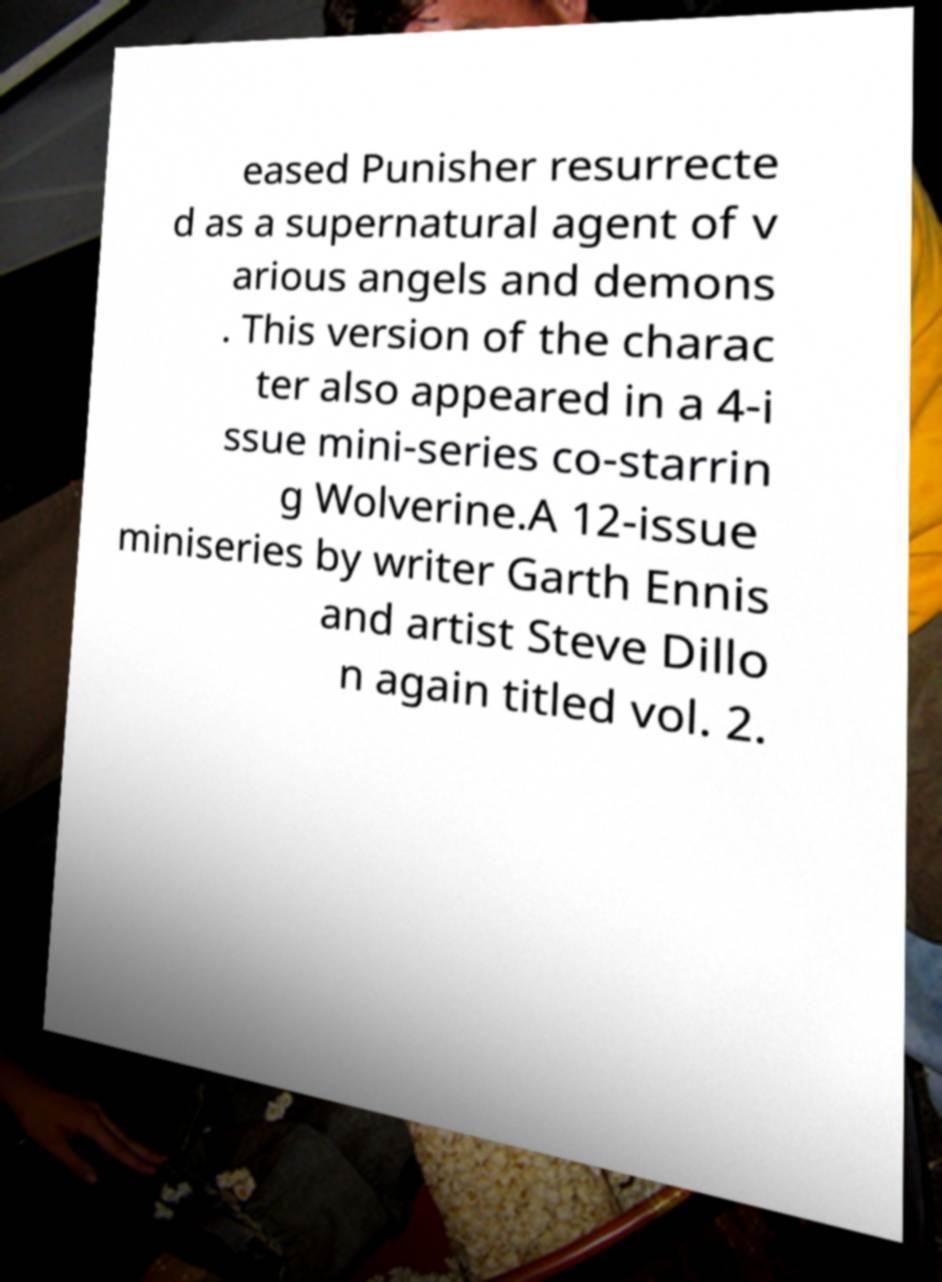There's text embedded in this image that I need extracted. Can you transcribe it verbatim? eased Punisher resurrecte d as a supernatural agent of v arious angels and demons . This version of the charac ter also appeared in a 4-i ssue mini-series co-starrin g Wolverine.A 12-issue miniseries by writer Garth Ennis and artist Steve Dillo n again titled vol. 2. 